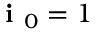Convert formula to latex. <formula><loc_0><loc_0><loc_500><loc_500>i _ { 0 } = 1</formula> 